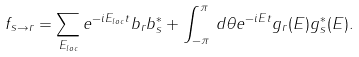Convert formula to latex. <formula><loc_0><loc_0><loc_500><loc_500>f _ { s \rightarrow r } = \sum _ { E _ { l o c } } e ^ { - i E _ { l o c } t } b _ { r } b _ { s } ^ { * } + \int _ { - \pi } ^ { \pi } \, d \theta e ^ { - i E t } g _ { r } ( E ) g _ { s } ^ { * } ( E ) .</formula> 